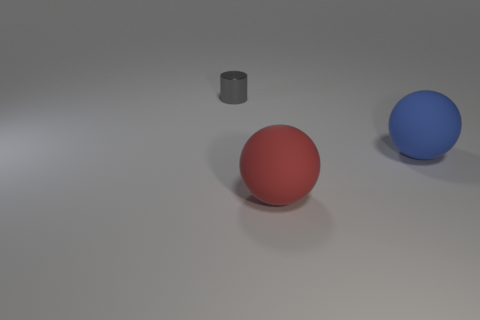Do the gray metal object and the object on the right side of the big red ball have the same size?
Ensure brevity in your answer.  No. There is a thing that is behind the matte object that is behind the ball in front of the large blue matte ball; what is its shape?
Offer a terse response. Cylinder. Is the number of green metallic cubes less than the number of large blue spheres?
Keep it short and to the point. Yes. Are there any big blue spheres to the left of the cylinder?
Keep it short and to the point. No. There is a thing that is left of the large blue ball and right of the cylinder; what shape is it?
Ensure brevity in your answer.  Sphere. Is there another big green metallic object of the same shape as the metallic object?
Your answer should be compact. No. There is a matte object on the left side of the blue thing; does it have the same size as the object on the right side of the big red matte ball?
Offer a terse response. Yes. Is the number of shiny cylinders greater than the number of large brown rubber cubes?
Offer a terse response. Yes. What number of other tiny gray cylinders are the same material as the tiny gray cylinder?
Your answer should be compact. 0. Do the small gray thing and the red rubber thing have the same shape?
Give a very brief answer. No. 